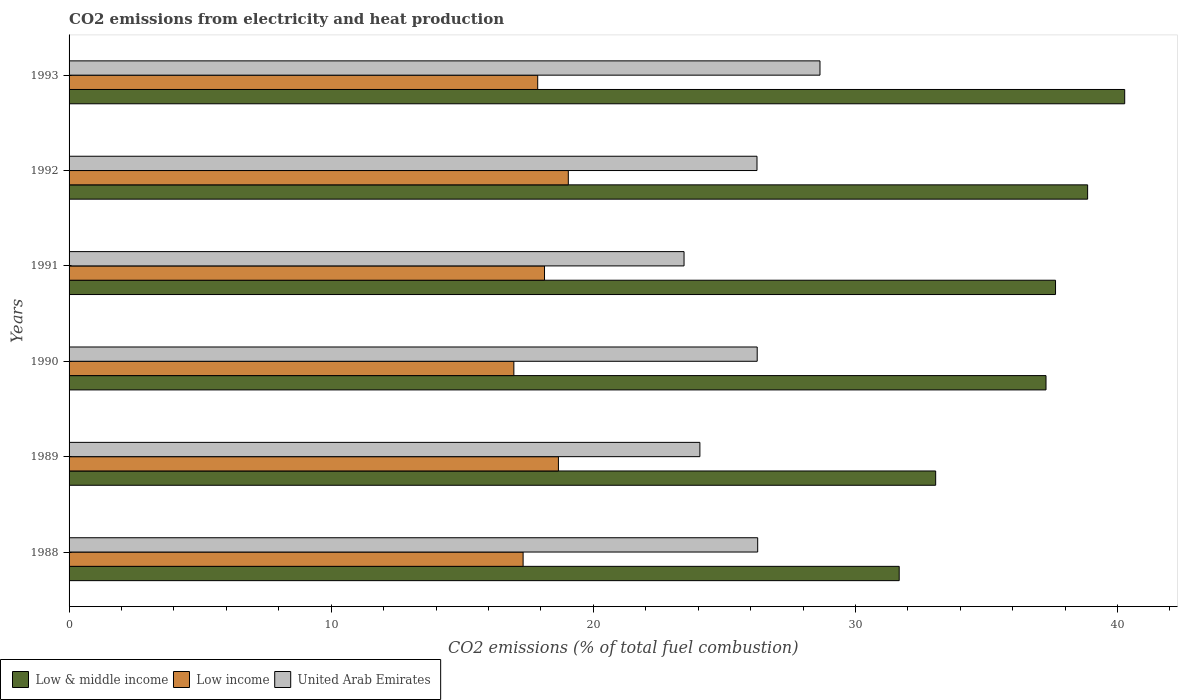How many bars are there on the 3rd tick from the top?
Keep it short and to the point. 3. How many bars are there on the 4th tick from the bottom?
Make the answer very short. 3. What is the label of the 6th group of bars from the top?
Give a very brief answer. 1988. What is the amount of CO2 emitted in Low & middle income in 1990?
Ensure brevity in your answer.  37.27. Across all years, what is the maximum amount of CO2 emitted in United Arab Emirates?
Your answer should be very brief. 28.65. Across all years, what is the minimum amount of CO2 emitted in Low income?
Your answer should be very brief. 16.97. In which year was the amount of CO2 emitted in Low & middle income maximum?
Your answer should be very brief. 1993. What is the total amount of CO2 emitted in Low income in the graph?
Your answer should be compact. 108.02. What is the difference between the amount of CO2 emitted in United Arab Emirates in 1990 and that in 1993?
Offer a very short reply. -2.4. What is the difference between the amount of CO2 emitted in Low income in 1988 and the amount of CO2 emitted in Low & middle income in 1991?
Provide a succinct answer. -20.31. What is the average amount of CO2 emitted in Low income per year?
Your answer should be very brief. 18. In the year 1992, what is the difference between the amount of CO2 emitted in Low & middle income and amount of CO2 emitted in Low income?
Provide a succinct answer. 19.81. What is the ratio of the amount of CO2 emitted in Low income in 1988 to that in 1992?
Keep it short and to the point. 0.91. What is the difference between the highest and the second highest amount of CO2 emitted in Low income?
Provide a short and direct response. 0.38. What is the difference between the highest and the lowest amount of CO2 emitted in United Arab Emirates?
Provide a succinct answer. 5.19. In how many years, is the amount of CO2 emitted in Low income greater than the average amount of CO2 emitted in Low income taken over all years?
Give a very brief answer. 3. What does the 3rd bar from the bottom in 1992 represents?
Your response must be concise. United Arab Emirates. Are all the bars in the graph horizontal?
Ensure brevity in your answer.  Yes. What is the difference between two consecutive major ticks on the X-axis?
Keep it short and to the point. 10. Are the values on the major ticks of X-axis written in scientific E-notation?
Provide a short and direct response. No. Does the graph contain any zero values?
Offer a terse response. No. Does the graph contain grids?
Keep it short and to the point. No. How many legend labels are there?
Your response must be concise. 3. What is the title of the graph?
Offer a terse response. CO2 emissions from electricity and heat production. Does "Thailand" appear as one of the legend labels in the graph?
Your answer should be compact. No. What is the label or title of the X-axis?
Make the answer very short. CO2 emissions (% of total fuel combustion). What is the CO2 emissions (% of total fuel combustion) of Low & middle income in 1988?
Offer a very short reply. 31.67. What is the CO2 emissions (% of total fuel combustion) in Low income in 1988?
Your answer should be very brief. 17.32. What is the CO2 emissions (% of total fuel combustion) of United Arab Emirates in 1988?
Offer a very short reply. 26.27. What is the CO2 emissions (% of total fuel combustion) in Low & middle income in 1989?
Offer a very short reply. 33.06. What is the CO2 emissions (% of total fuel combustion) in Low income in 1989?
Your response must be concise. 18.67. What is the CO2 emissions (% of total fuel combustion) of United Arab Emirates in 1989?
Your answer should be compact. 24.07. What is the CO2 emissions (% of total fuel combustion) in Low & middle income in 1990?
Provide a short and direct response. 37.27. What is the CO2 emissions (% of total fuel combustion) in Low income in 1990?
Ensure brevity in your answer.  16.97. What is the CO2 emissions (% of total fuel combustion) of United Arab Emirates in 1990?
Ensure brevity in your answer.  26.25. What is the CO2 emissions (% of total fuel combustion) in Low & middle income in 1991?
Your answer should be very brief. 37.63. What is the CO2 emissions (% of total fuel combustion) in Low income in 1991?
Make the answer very short. 18.14. What is the CO2 emissions (% of total fuel combustion) of United Arab Emirates in 1991?
Offer a very short reply. 23.46. What is the CO2 emissions (% of total fuel combustion) in Low & middle income in 1992?
Ensure brevity in your answer.  38.86. What is the CO2 emissions (% of total fuel combustion) in Low income in 1992?
Provide a short and direct response. 19.05. What is the CO2 emissions (% of total fuel combustion) in United Arab Emirates in 1992?
Provide a succinct answer. 26.25. What is the CO2 emissions (% of total fuel combustion) of Low & middle income in 1993?
Offer a terse response. 40.27. What is the CO2 emissions (% of total fuel combustion) of Low income in 1993?
Offer a terse response. 17.88. What is the CO2 emissions (% of total fuel combustion) of United Arab Emirates in 1993?
Your answer should be compact. 28.65. Across all years, what is the maximum CO2 emissions (% of total fuel combustion) of Low & middle income?
Provide a short and direct response. 40.27. Across all years, what is the maximum CO2 emissions (% of total fuel combustion) of Low income?
Offer a very short reply. 19.05. Across all years, what is the maximum CO2 emissions (% of total fuel combustion) in United Arab Emirates?
Your answer should be very brief. 28.65. Across all years, what is the minimum CO2 emissions (% of total fuel combustion) of Low & middle income?
Ensure brevity in your answer.  31.67. Across all years, what is the minimum CO2 emissions (% of total fuel combustion) in Low income?
Make the answer very short. 16.97. Across all years, what is the minimum CO2 emissions (% of total fuel combustion) in United Arab Emirates?
Keep it short and to the point. 23.46. What is the total CO2 emissions (% of total fuel combustion) of Low & middle income in the graph?
Your response must be concise. 218.77. What is the total CO2 emissions (% of total fuel combustion) in Low income in the graph?
Offer a very short reply. 108.02. What is the total CO2 emissions (% of total fuel combustion) in United Arab Emirates in the graph?
Make the answer very short. 154.95. What is the difference between the CO2 emissions (% of total fuel combustion) in Low & middle income in 1988 and that in 1989?
Your answer should be compact. -1.39. What is the difference between the CO2 emissions (% of total fuel combustion) of Low income in 1988 and that in 1989?
Provide a short and direct response. -1.35. What is the difference between the CO2 emissions (% of total fuel combustion) in United Arab Emirates in 1988 and that in 1989?
Provide a short and direct response. 2.21. What is the difference between the CO2 emissions (% of total fuel combustion) of Low & middle income in 1988 and that in 1990?
Your response must be concise. -5.6. What is the difference between the CO2 emissions (% of total fuel combustion) in Low income in 1988 and that in 1990?
Your response must be concise. 0.35. What is the difference between the CO2 emissions (% of total fuel combustion) in United Arab Emirates in 1988 and that in 1990?
Your answer should be very brief. 0.02. What is the difference between the CO2 emissions (% of total fuel combustion) of Low & middle income in 1988 and that in 1991?
Offer a terse response. -5.96. What is the difference between the CO2 emissions (% of total fuel combustion) in Low income in 1988 and that in 1991?
Provide a succinct answer. -0.82. What is the difference between the CO2 emissions (% of total fuel combustion) in United Arab Emirates in 1988 and that in 1991?
Keep it short and to the point. 2.81. What is the difference between the CO2 emissions (% of total fuel combustion) in Low & middle income in 1988 and that in 1992?
Provide a succinct answer. -7.19. What is the difference between the CO2 emissions (% of total fuel combustion) in Low income in 1988 and that in 1992?
Provide a succinct answer. -1.72. What is the difference between the CO2 emissions (% of total fuel combustion) of United Arab Emirates in 1988 and that in 1992?
Your answer should be very brief. 0.03. What is the difference between the CO2 emissions (% of total fuel combustion) in Low & middle income in 1988 and that in 1993?
Keep it short and to the point. -8.6. What is the difference between the CO2 emissions (% of total fuel combustion) in Low income in 1988 and that in 1993?
Offer a terse response. -0.56. What is the difference between the CO2 emissions (% of total fuel combustion) in United Arab Emirates in 1988 and that in 1993?
Offer a very short reply. -2.38. What is the difference between the CO2 emissions (% of total fuel combustion) of Low & middle income in 1989 and that in 1990?
Your response must be concise. -4.21. What is the difference between the CO2 emissions (% of total fuel combustion) in Low income in 1989 and that in 1990?
Provide a short and direct response. 1.7. What is the difference between the CO2 emissions (% of total fuel combustion) in United Arab Emirates in 1989 and that in 1990?
Your answer should be very brief. -2.19. What is the difference between the CO2 emissions (% of total fuel combustion) in Low & middle income in 1989 and that in 1991?
Make the answer very short. -4.57. What is the difference between the CO2 emissions (% of total fuel combustion) of Low income in 1989 and that in 1991?
Your response must be concise. 0.53. What is the difference between the CO2 emissions (% of total fuel combustion) in United Arab Emirates in 1989 and that in 1991?
Make the answer very short. 0.6. What is the difference between the CO2 emissions (% of total fuel combustion) of Low & middle income in 1989 and that in 1992?
Your response must be concise. -5.8. What is the difference between the CO2 emissions (% of total fuel combustion) in Low income in 1989 and that in 1992?
Provide a short and direct response. -0.38. What is the difference between the CO2 emissions (% of total fuel combustion) of United Arab Emirates in 1989 and that in 1992?
Make the answer very short. -2.18. What is the difference between the CO2 emissions (% of total fuel combustion) of Low & middle income in 1989 and that in 1993?
Your answer should be compact. -7.21. What is the difference between the CO2 emissions (% of total fuel combustion) of Low income in 1989 and that in 1993?
Provide a short and direct response. 0.79. What is the difference between the CO2 emissions (% of total fuel combustion) of United Arab Emirates in 1989 and that in 1993?
Your answer should be compact. -4.58. What is the difference between the CO2 emissions (% of total fuel combustion) in Low & middle income in 1990 and that in 1991?
Your answer should be very brief. -0.36. What is the difference between the CO2 emissions (% of total fuel combustion) in Low income in 1990 and that in 1991?
Keep it short and to the point. -1.17. What is the difference between the CO2 emissions (% of total fuel combustion) in United Arab Emirates in 1990 and that in 1991?
Your response must be concise. 2.79. What is the difference between the CO2 emissions (% of total fuel combustion) in Low & middle income in 1990 and that in 1992?
Your answer should be very brief. -1.59. What is the difference between the CO2 emissions (% of total fuel combustion) of Low income in 1990 and that in 1992?
Your response must be concise. -2.08. What is the difference between the CO2 emissions (% of total fuel combustion) in United Arab Emirates in 1990 and that in 1992?
Your answer should be very brief. 0.01. What is the difference between the CO2 emissions (% of total fuel combustion) in Low & middle income in 1990 and that in 1993?
Your answer should be compact. -3. What is the difference between the CO2 emissions (% of total fuel combustion) in Low income in 1990 and that in 1993?
Keep it short and to the point. -0.91. What is the difference between the CO2 emissions (% of total fuel combustion) in United Arab Emirates in 1990 and that in 1993?
Keep it short and to the point. -2.4. What is the difference between the CO2 emissions (% of total fuel combustion) in Low & middle income in 1991 and that in 1992?
Provide a short and direct response. -1.22. What is the difference between the CO2 emissions (% of total fuel combustion) of Low income in 1991 and that in 1992?
Offer a very short reply. -0.91. What is the difference between the CO2 emissions (% of total fuel combustion) of United Arab Emirates in 1991 and that in 1992?
Your answer should be compact. -2.78. What is the difference between the CO2 emissions (% of total fuel combustion) of Low & middle income in 1991 and that in 1993?
Offer a terse response. -2.64. What is the difference between the CO2 emissions (% of total fuel combustion) in Low income in 1991 and that in 1993?
Provide a succinct answer. 0.26. What is the difference between the CO2 emissions (% of total fuel combustion) in United Arab Emirates in 1991 and that in 1993?
Offer a terse response. -5.19. What is the difference between the CO2 emissions (% of total fuel combustion) of Low & middle income in 1992 and that in 1993?
Offer a very short reply. -1.41. What is the difference between the CO2 emissions (% of total fuel combustion) in Low income in 1992 and that in 1993?
Ensure brevity in your answer.  1.17. What is the difference between the CO2 emissions (% of total fuel combustion) of United Arab Emirates in 1992 and that in 1993?
Provide a succinct answer. -2.4. What is the difference between the CO2 emissions (% of total fuel combustion) in Low & middle income in 1988 and the CO2 emissions (% of total fuel combustion) in Low income in 1989?
Give a very brief answer. 13. What is the difference between the CO2 emissions (% of total fuel combustion) of Low & middle income in 1988 and the CO2 emissions (% of total fuel combustion) of United Arab Emirates in 1989?
Ensure brevity in your answer.  7.6. What is the difference between the CO2 emissions (% of total fuel combustion) in Low income in 1988 and the CO2 emissions (% of total fuel combustion) in United Arab Emirates in 1989?
Offer a very short reply. -6.74. What is the difference between the CO2 emissions (% of total fuel combustion) of Low & middle income in 1988 and the CO2 emissions (% of total fuel combustion) of Low income in 1990?
Your answer should be compact. 14.7. What is the difference between the CO2 emissions (% of total fuel combustion) in Low & middle income in 1988 and the CO2 emissions (% of total fuel combustion) in United Arab Emirates in 1990?
Make the answer very short. 5.42. What is the difference between the CO2 emissions (% of total fuel combustion) in Low income in 1988 and the CO2 emissions (% of total fuel combustion) in United Arab Emirates in 1990?
Offer a terse response. -8.93. What is the difference between the CO2 emissions (% of total fuel combustion) of Low & middle income in 1988 and the CO2 emissions (% of total fuel combustion) of Low income in 1991?
Provide a short and direct response. 13.53. What is the difference between the CO2 emissions (% of total fuel combustion) of Low & middle income in 1988 and the CO2 emissions (% of total fuel combustion) of United Arab Emirates in 1991?
Your answer should be compact. 8.21. What is the difference between the CO2 emissions (% of total fuel combustion) in Low income in 1988 and the CO2 emissions (% of total fuel combustion) in United Arab Emirates in 1991?
Provide a succinct answer. -6.14. What is the difference between the CO2 emissions (% of total fuel combustion) in Low & middle income in 1988 and the CO2 emissions (% of total fuel combustion) in Low income in 1992?
Provide a short and direct response. 12.62. What is the difference between the CO2 emissions (% of total fuel combustion) of Low & middle income in 1988 and the CO2 emissions (% of total fuel combustion) of United Arab Emirates in 1992?
Your answer should be very brief. 5.43. What is the difference between the CO2 emissions (% of total fuel combustion) in Low income in 1988 and the CO2 emissions (% of total fuel combustion) in United Arab Emirates in 1992?
Offer a very short reply. -8.92. What is the difference between the CO2 emissions (% of total fuel combustion) in Low & middle income in 1988 and the CO2 emissions (% of total fuel combustion) in Low income in 1993?
Offer a terse response. 13.79. What is the difference between the CO2 emissions (% of total fuel combustion) of Low & middle income in 1988 and the CO2 emissions (% of total fuel combustion) of United Arab Emirates in 1993?
Provide a short and direct response. 3.02. What is the difference between the CO2 emissions (% of total fuel combustion) in Low income in 1988 and the CO2 emissions (% of total fuel combustion) in United Arab Emirates in 1993?
Provide a short and direct response. -11.33. What is the difference between the CO2 emissions (% of total fuel combustion) of Low & middle income in 1989 and the CO2 emissions (% of total fuel combustion) of Low income in 1990?
Offer a very short reply. 16.09. What is the difference between the CO2 emissions (% of total fuel combustion) in Low & middle income in 1989 and the CO2 emissions (% of total fuel combustion) in United Arab Emirates in 1990?
Provide a short and direct response. 6.81. What is the difference between the CO2 emissions (% of total fuel combustion) of Low income in 1989 and the CO2 emissions (% of total fuel combustion) of United Arab Emirates in 1990?
Your answer should be very brief. -7.58. What is the difference between the CO2 emissions (% of total fuel combustion) in Low & middle income in 1989 and the CO2 emissions (% of total fuel combustion) in Low income in 1991?
Your response must be concise. 14.92. What is the difference between the CO2 emissions (% of total fuel combustion) in Low & middle income in 1989 and the CO2 emissions (% of total fuel combustion) in United Arab Emirates in 1991?
Ensure brevity in your answer.  9.6. What is the difference between the CO2 emissions (% of total fuel combustion) of Low income in 1989 and the CO2 emissions (% of total fuel combustion) of United Arab Emirates in 1991?
Keep it short and to the point. -4.79. What is the difference between the CO2 emissions (% of total fuel combustion) of Low & middle income in 1989 and the CO2 emissions (% of total fuel combustion) of Low income in 1992?
Give a very brief answer. 14.02. What is the difference between the CO2 emissions (% of total fuel combustion) in Low & middle income in 1989 and the CO2 emissions (% of total fuel combustion) in United Arab Emirates in 1992?
Ensure brevity in your answer.  6.82. What is the difference between the CO2 emissions (% of total fuel combustion) of Low income in 1989 and the CO2 emissions (% of total fuel combustion) of United Arab Emirates in 1992?
Offer a terse response. -7.58. What is the difference between the CO2 emissions (% of total fuel combustion) of Low & middle income in 1989 and the CO2 emissions (% of total fuel combustion) of Low income in 1993?
Your answer should be compact. 15.18. What is the difference between the CO2 emissions (% of total fuel combustion) of Low & middle income in 1989 and the CO2 emissions (% of total fuel combustion) of United Arab Emirates in 1993?
Give a very brief answer. 4.41. What is the difference between the CO2 emissions (% of total fuel combustion) of Low income in 1989 and the CO2 emissions (% of total fuel combustion) of United Arab Emirates in 1993?
Offer a very short reply. -9.98. What is the difference between the CO2 emissions (% of total fuel combustion) of Low & middle income in 1990 and the CO2 emissions (% of total fuel combustion) of Low income in 1991?
Offer a terse response. 19.13. What is the difference between the CO2 emissions (% of total fuel combustion) in Low & middle income in 1990 and the CO2 emissions (% of total fuel combustion) in United Arab Emirates in 1991?
Offer a terse response. 13.81. What is the difference between the CO2 emissions (% of total fuel combustion) of Low income in 1990 and the CO2 emissions (% of total fuel combustion) of United Arab Emirates in 1991?
Offer a very short reply. -6.49. What is the difference between the CO2 emissions (% of total fuel combustion) in Low & middle income in 1990 and the CO2 emissions (% of total fuel combustion) in Low income in 1992?
Give a very brief answer. 18.23. What is the difference between the CO2 emissions (% of total fuel combustion) of Low & middle income in 1990 and the CO2 emissions (% of total fuel combustion) of United Arab Emirates in 1992?
Your response must be concise. 11.03. What is the difference between the CO2 emissions (% of total fuel combustion) of Low income in 1990 and the CO2 emissions (% of total fuel combustion) of United Arab Emirates in 1992?
Give a very brief answer. -9.28. What is the difference between the CO2 emissions (% of total fuel combustion) of Low & middle income in 1990 and the CO2 emissions (% of total fuel combustion) of Low income in 1993?
Your answer should be very brief. 19.39. What is the difference between the CO2 emissions (% of total fuel combustion) of Low & middle income in 1990 and the CO2 emissions (% of total fuel combustion) of United Arab Emirates in 1993?
Your response must be concise. 8.62. What is the difference between the CO2 emissions (% of total fuel combustion) of Low income in 1990 and the CO2 emissions (% of total fuel combustion) of United Arab Emirates in 1993?
Provide a short and direct response. -11.68. What is the difference between the CO2 emissions (% of total fuel combustion) of Low & middle income in 1991 and the CO2 emissions (% of total fuel combustion) of Low income in 1992?
Offer a terse response. 18.59. What is the difference between the CO2 emissions (% of total fuel combustion) in Low & middle income in 1991 and the CO2 emissions (% of total fuel combustion) in United Arab Emirates in 1992?
Provide a succinct answer. 11.39. What is the difference between the CO2 emissions (% of total fuel combustion) of Low income in 1991 and the CO2 emissions (% of total fuel combustion) of United Arab Emirates in 1992?
Your answer should be compact. -8.11. What is the difference between the CO2 emissions (% of total fuel combustion) in Low & middle income in 1991 and the CO2 emissions (% of total fuel combustion) in Low income in 1993?
Your answer should be compact. 19.76. What is the difference between the CO2 emissions (% of total fuel combustion) of Low & middle income in 1991 and the CO2 emissions (% of total fuel combustion) of United Arab Emirates in 1993?
Offer a very short reply. 8.99. What is the difference between the CO2 emissions (% of total fuel combustion) in Low income in 1991 and the CO2 emissions (% of total fuel combustion) in United Arab Emirates in 1993?
Give a very brief answer. -10.51. What is the difference between the CO2 emissions (% of total fuel combustion) of Low & middle income in 1992 and the CO2 emissions (% of total fuel combustion) of Low income in 1993?
Ensure brevity in your answer.  20.98. What is the difference between the CO2 emissions (% of total fuel combustion) of Low & middle income in 1992 and the CO2 emissions (% of total fuel combustion) of United Arab Emirates in 1993?
Offer a very short reply. 10.21. What is the difference between the CO2 emissions (% of total fuel combustion) of Low income in 1992 and the CO2 emissions (% of total fuel combustion) of United Arab Emirates in 1993?
Provide a short and direct response. -9.6. What is the average CO2 emissions (% of total fuel combustion) in Low & middle income per year?
Give a very brief answer. 36.46. What is the average CO2 emissions (% of total fuel combustion) of Low income per year?
Provide a short and direct response. 18. What is the average CO2 emissions (% of total fuel combustion) of United Arab Emirates per year?
Provide a short and direct response. 25.82. In the year 1988, what is the difference between the CO2 emissions (% of total fuel combustion) of Low & middle income and CO2 emissions (% of total fuel combustion) of Low income?
Make the answer very short. 14.35. In the year 1988, what is the difference between the CO2 emissions (% of total fuel combustion) in Low & middle income and CO2 emissions (% of total fuel combustion) in United Arab Emirates?
Your answer should be compact. 5.4. In the year 1988, what is the difference between the CO2 emissions (% of total fuel combustion) of Low income and CO2 emissions (% of total fuel combustion) of United Arab Emirates?
Make the answer very short. -8.95. In the year 1989, what is the difference between the CO2 emissions (% of total fuel combustion) of Low & middle income and CO2 emissions (% of total fuel combustion) of Low income?
Provide a succinct answer. 14.39. In the year 1989, what is the difference between the CO2 emissions (% of total fuel combustion) in Low & middle income and CO2 emissions (% of total fuel combustion) in United Arab Emirates?
Keep it short and to the point. 9. In the year 1989, what is the difference between the CO2 emissions (% of total fuel combustion) in Low income and CO2 emissions (% of total fuel combustion) in United Arab Emirates?
Your response must be concise. -5.4. In the year 1990, what is the difference between the CO2 emissions (% of total fuel combustion) of Low & middle income and CO2 emissions (% of total fuel combustion) of Low income?
Give a very brief answer. 20.3. In the year 1990, what is the difference between the CO2 emissions (% of total fuel combustion) of Low & middle income and CO2 emissions (% of total fuel combustion) of United Arab Emirates?
Your response must be concise. 11.02. In the year 1990, what is the difference between the CO2 emissions (% of total fuel combustion) in Low income and CO2 emissions (% of total fuel combustion) in United Arab Emirates?
Make the answer very short. -9.28. In the year 1991, what is the difference between the CO2 emissions (% of total fuel combustion) of Low & middle income and CO2 emissions (% of total fuel combustion) of Low income?
Offer a very short reply. 19.5. In the year 1991, what is the difference between the CO2 emissions (% of total fuel combustion) in Low & middle income and CO2 emissions (% of total fuel combustion) in United Arab Emirates?
Your answer should be very brief. 14.17. In the year 1991, what is the difference between the CO2 emissions (% of total fuel combustion) in Low income and CO2 emissions (% of total fuel combustion) in United Arab Emirates?
Provide a short and direct response. -5.32. In the year 1992, what is the difference between the CO2 emissions (% of total fuel combustion) of Low & middle income and CO2 emissions (% of total fuel combustion) of Low income?
Your answer should be very brief. 19.81. In the year 1992, what is the difference between the CO2 emissions (% of total fuel combustion) in Low & middle income and CO2 emissions (% of total fuel combustion) in United Arab Emirates?
Offer a very short reply. 12.61. In the year 1992, what is the difference between the CO2 emissions (% of total fuel combustion) of Low income and CO2 emissions (% of total fuel combustion) of United Arab Emirates?
Make the answer very short. -7.2. In the year 1993, what is the difference between the CO2 emissions (% of total fuel combustion) of Low & middle income and CO2 emissions (% of total fuel combustion) of Low income?
Your response must be concise. 22.39. In the year 1993, what is the difference between the CO2 emissions (% of total fuel combustion) in Low & middle income and CO2 emissions (% of total fuel combustion) in United Arab Emirates?
Make the answer very short. 11.63. In the year 1993, what is the difference between the CO2 emissions (% of total fuel combustion) in Low income and CO2 emissions (% of total fuel combustion) in United Arab Emirates?
Your answer should be very brief. -10.77. What is the ratio of the CO2 emissions (% of total fuel combustion) of Low & middle income in 1988 to that in 1989?
Keep it short and to the point. 0.96. What is the ratio of the CO2 emissions (% of total fuel combustion) in Low income in 1988 to that in 1989?
Your answer should be compact. 0.93. What is the ratio of the CO2 emissions (% of total fuel combustion) in United Arab Emirates in 1988 to that in 1989?
Offer a very short reply. 1.09. What is the ratio of the CO2 emissions (% of total fuel combustion) in Low & middle income in 1988 to that in 1990?
Offer a terse response. 0.85. What is the ratio of the CO2 emissions (% of total fuel combustion) of Low income in 1988 to that in 1990?
Your answer should be very brief. 1.02. What is the ratio of the CO2 emissions (% of total fuel combustion) of Low & middle income in 1988 to that in 1991?
Your answer should be compact. 0.84. What is the ratio of the CO2 emissions (% of total fuel combustion) in Low income in 1988 to that in 1991?
Your answer should be compact. 0.95. What is the ratio of the CO2 emissions (% of total fuel combustion) in United Arab Emirates in 1988 to that in 1991?
Provide a short and direct response. 1.12. What is the ratio of the CO2 emissions (% of total fuel combustion) of Low & middle income in 1988 to that in 1992?
Offer a very short reply. 0.81. What is the ratio of the CO2 emissions (% of total fuel combustion) in Low income in 1988 to that in 1992?
Your answer should be very brief. 0.91. What is the ratio of the CO2 emissions (% of total fuel combustion) of United Arab Emirates in 1988 to that in 1992?
Your answer should be very brief. 1. What is the ratio of the CO2 emissions (% of total fuel combustion) of Low & middle income in 1988 to that in 1993?
Your response must be concise. 0.79. What is the ratio of the CO2 emissions (% of total fuel combustion) in Low income in 1988 to that in 1993?
Keep it short and to the point. 0.97. What is the ratio of the CO2 emissions (% of total fuel combustion) of United Arab Emirates in 1988 to that in 1993?
Keep it short and to the point. 0.92. What is the ratio of the CO2 emissions (% of total fuel combustion) in Low & middle income in 1989 to that in 1990?
Your response must be concise. 0.89. What is the ratio of the CO2 emissions (% of total fuel combustion) of Low income in 1989 to that in 1990?
Provide a short and direct response. 1.1. What is the ratio of the CO2 emissions (% of total fuel combustion) in United Arab Emirates in 1989 to that in 1990?
Your answer should be very brief. 0.92. What is the ratio of the CO2 emissions (% of total fuel combustion) in Low & middle income in 1989 to that in 1991?
Provide a succinct answer. 0.88. What is the ratio of the CO2 emissions (% of total fuel combustion) of Low income in 1989 to that in 1991?
Make the answer very short. 1.03. What is the ratio of the CO2 emissions (% of total fuel combustion) of United Arab Emirates in 1989 to that in 1991?
Your response must be concise. 1.03. What is the ratio of the CO2 emissions (% of total fuel combustion) in Low & middle income in 1989 to that in 1992?
Provide a short and direct response. 0.85. What is the ratio of the CO2 emissions (% of total fuel combustion) in Low income in 1989 to that in 1992?
Offer a terse response. 0.98. What is the ratio of the CO2 emissions (% of total fuel combustion) of United Arab Emirates in 1989 to that in 1992?
Your answer should be compact. 0.92. What is the ratio of the CO2 emissions (% of total fuel combustion) of Low & middle income in 1989 to that in 1993?
Keep it short and to the point. 0.82. What is the ratio of the CO2 emissions (% of total fuel combustion) in Low income in 1989 to that in 1993?
Offer a terse response. 1.04. What is the ratio of the CO2 emissions (% of total fuel combustion) of United Arab Emirates in 1989 to that in 1993?
Offer a very short reply. 0.84. What is the ratio of the CO2 emissions (% of total fuel combustion) in Low & middle income in 1990 to that in 1991?
Your response must be concise. 0.99. What is the ratio of the CO2 emissions (% of total fuel combustion) of Low income in 1990 to that in 1991?
Provide a short and direct response. 0.94. What is the ratio of the CO2 emissions (% of total fuel combustion) in United Arab Emirates in 1990 to that in 1991?
Offer a terse response. 1.12. What is the ratio of the CO2 emissions (% of total fuel combustion) in Low & middle income in 1990 to that in 1992?
Make the answer very short. 0.96. What is the ratio of the CO2 emissions (% of total fuel combustion) in Low income in 1990 to that in 1992?
Keep it short and to the point. 0.89. What is the ratio of the CO2 emissions (% of total fuel combustion) in United Arab Emirates in 1990 to that in 1992?
Your answer should be very brief. 1. What is the ratio of the CO2 emissions (% of total fuel combustion) in Low & middle income in 1990 to that in 1993?
Make the answer very short. 0.93. What is the ratio of the CO2 emissions (% of total fuel combustion) of Low income in 1990 to that in 1993?
Provide a succinct answer. 0.95. What is the ratio of the CO2 emissions (% of total fuel combustion) in United Arab Emirates in 1990 to that in 1993?
Ensure brevity in your answer.  0.92. What is the ratio of the CO2 emissions (% of total fuel combustion) in Low & middle income in 1991 to that in 1992?
Provide a short and direct response. 0.97. What is the ratio of the CO2 emissions (% of total fuel combustion) of Low income in 1991 to that in 1992?
Your answer should be very brief. 0.95. What is the ratio of the CO2 emissions (% of total fuel combustion) of United Arab Emirates in 1991 to that in 1992?
Offer a very short reply. 0.89. What is the ratio of the CO2 emissions (% of total fuel combustion) of Low & middle income in 1991 to that in 1993?
Make the answer very short. 0.93. What is the ratio of the CO2 emissions (% of total fuel combustion) in Low income in 1991 to that in 1993?
Provide a short and direct response. 1.01. What is the ratio of the CO2 emissions (% of total fuel combustion) of United Arab Emirates in 1991 to that in 1993?
Provide a succinct answer. 0.82. What is the ratio of the CO2 emissions (% of total fuel combustion) in Low & middle income in 1992 to that in 1993?
Your answer should be compact. 0.96. What is the ratio of the CO2 emissions (% of total fuel combustion) of Low income in 1992 to that in 1993?
Provide a succinct answer. 1.07. What is the ratio of the CO2 emissions (% of total fuel combustion) in United Arab Emirates in 1992 to that in 1993?
Offer a very short reply. 0.92. What is the difference between the highest and the second highest CO2 emissions (% of total fuel combustion) in Low & middle income?
Ensure brevity in your answer.  1.41. What is the difference between the highest and the second highest CO2 emissions (% of total fuel combustion) of Low income?
Keep it short and to the point. 0.38. What is the difference between the highest and the second highest CO2 emissions (% of total fuel combustion) of United Arab Emirates?
Ensure brevity in your answer.  2.38. What is the difference between the highest and the lowest CO2 emissions (% of total fuel combustion) of Low & middle income?
Give a very brief answer. 8.6. What is the difference between the highest and the lowest CO2 emissions (% of total fuel combustion) in Low income?
Provide a succinct answer. 2.08. What is the difference between the highest and the lowest CO2 emissions (% of total fuel combustion) of United Arab Emirates?
Ensure brevity in your answer.  5.19. 